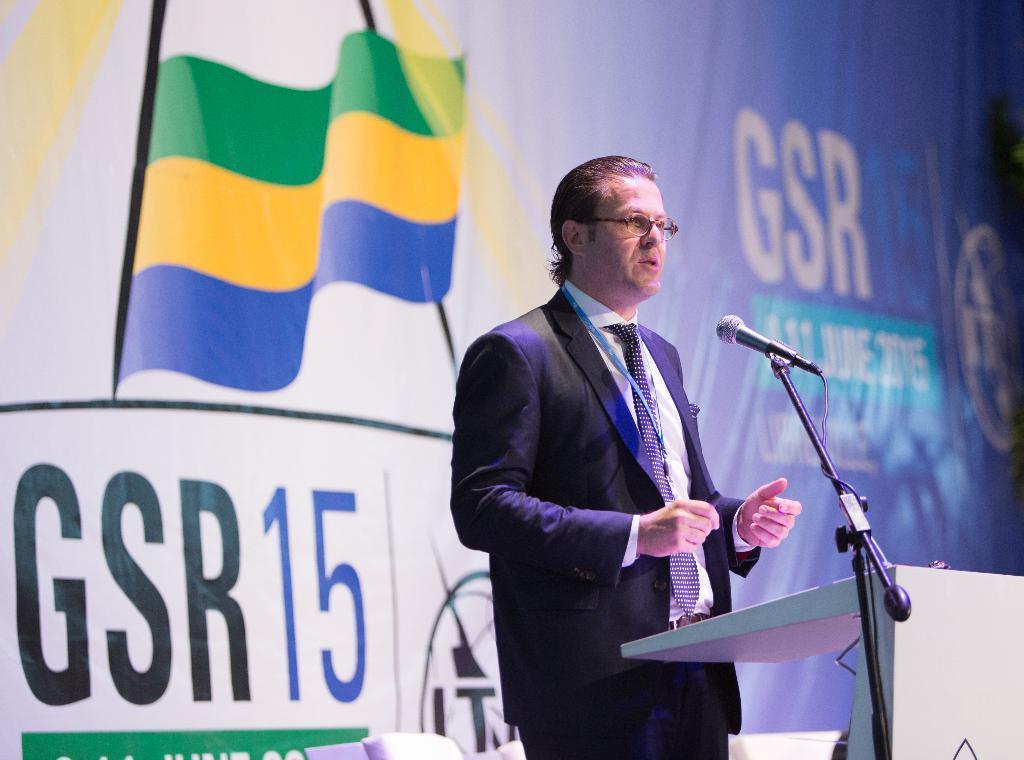Can you describe this image briefly? In this image we can see a man wearing the glasses and also the suit and standing in front of the podium. We can also see the mike with the stand. In the background there is a banner with the text. 